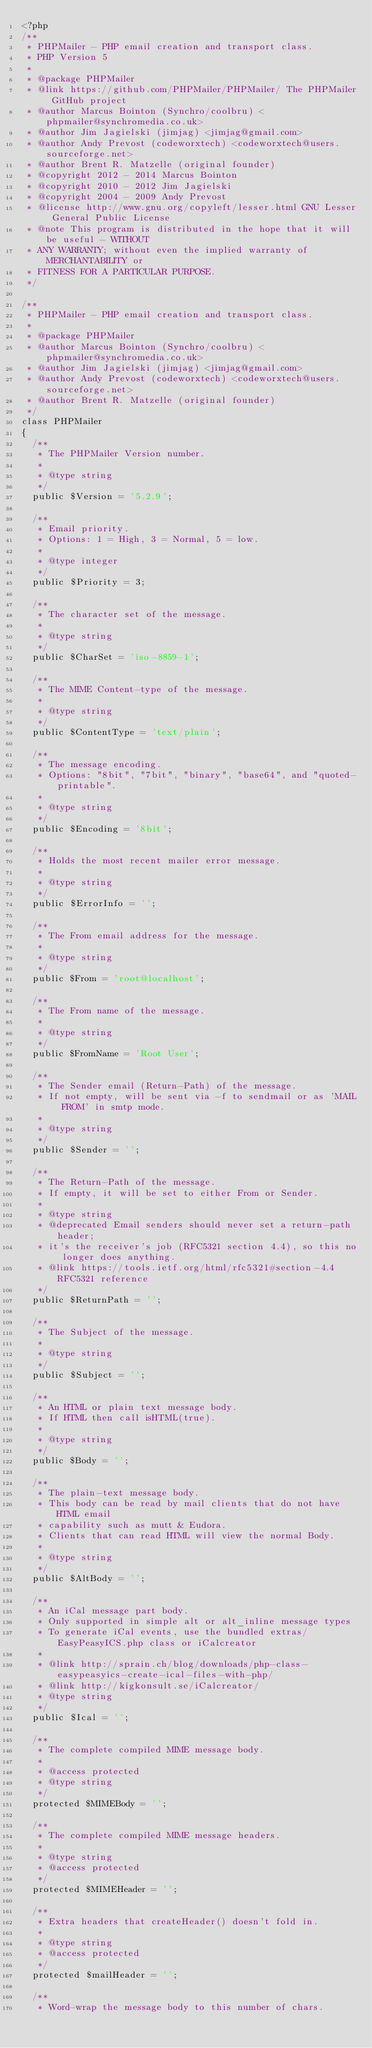<code> <loc_0><loc_0><loc_500><loc_500><_PHP_><?php
/**
 * PHPMailer - PHP email creation and transport class.
 * PHP Version 5
 *
 * @package PHPMailer
 * @link https://github.com/PHPMailer/PHPMailer/ The PHPMailer GitHub project
 * @author Marcus Bointon (Synchro/coolbru) <phpmailer@synchromedia.co.uk>
 * @author Jim Jagielski (jimjag) <jimjag@gmail.com>
 * @author Andy Prevost (codeworxtech) <codeworxtech@users.sourceforge.net>
 * @author Brent R. Matzelle (original founder)
 * @copyright 2012 - 2014 Marcus Bointon
 * @copyright 2010 - 2012 Jim Jagielski
 * @copyright 2004 - 2009 Andy Prevost
 * @license http://www.gnu.org/copyleft/lesser.html GNU Lesser General Public License
 * @note This program is distributed in the hope that it will be useful - WITHOUT
 * ANY WARRANTY; without even the implied warranty of MERCHANTABILITY or
 * FITNESS FOR A PARTICULAR PURPOSE.
 */

/**
 * PHPMailer - PHP email creation and transport class.
 *
 * @package PHPMailer
 * @author Marcus Bointon (Synchro/coolbru) <phpmailer@synchromedia.co.uk>
 * @author Jim Jagielski (jimjag) <jimjag@gmail.com>
 * @author Andy Prevost (codeworxtech) <codeworxtech@users.sourceforge.net>
 * @author Brent R. Matzelle (original founder)
 */
class PHPMailer
{
	/**
	 * The PHPMailer Version number.
	 *
	 * @type string
	 */
	public $Version = '5.2.9';

	/**
	 * Email priority.
	 * Options: 1 = High, 3 = Normal, 5 = low.
	 *
	 * @type integer
	 */
	public $Priority = 3;

	/**
	 * The character set of the message.
	 *
	 * @type string
	 */
	public $CharSet = 'iso-8859-1';

	/**
	 * The MIME Content-type of the message.
	 *
	 * @type string
	 */
	public $ContentType = 'text/plain';

	/**
	 * The message encoding.
	 * Options: "8bit", "7bit", "binary", "base64", and "quoted-printable".
	 *
	 * @type string
	 */
	public $Encoding = '8bit';

	/**
	 * Holds the most recent mailer error message.
	 *
	 * @type string
	 */
	public $ErrorInfo = '';

	/**
	 * The From email address for the message.
	 *
	 * @type string
	 */
	public $From = 'root@localhost';

	/**
	 * The From name of the message.
	 *
	 * @type string
	 */
	public $FromName = 'Root User';

	/**
	 * The Sender email (Return-Path) of the message.
	 * If not empty, will be sent via -f to sendmail or as 'MAIL FROM' in smtp mode.
	 *
	 * @type string
	 */
	public $Sender = '';

	/**
	 * The Return-Path of the message.
	 * If empty, it will be set to either From or Sender.
	 *
	 * @type string
	 * @deprecated Email senders should never set a return-path header;
	 * it's the receiver's job (RFC5321 section 4.4), so this no longer does anything.
	 * @link https://tools.ietf.org/html/rfc5321#section-4.4 RFC5321 reference
	 */
	public $ReturnPath = '';

	/**
	 * The Subject of the message.
	 *
	 * @type string
	 */
	public $Subject = '';

	/**
	 * An HTML or plain text message body.
	 * If HTML then call isHTML(true).
	 *
	 * @type string
	 */
	public $Body = '';

	/**
	 * The plain-text message body.
	 * This body can be read by mail clients that do not have HTML email
	 * capability such as mutt & Eudora.
	 * Clients that can read HTML will view the normal Body.
	 *
	 * @type string
	 */
	public $AltBody = '';

	/**
	 * An iCal message part body.
	 * Only supported in simple alt or alt_inline message types
	 * To generate iCal events, use the bundled extras/EasyPeasyICS.php class or iCalcreator
	 *
	 * @link http://sprain.ch/blog/downloads/php-class-easypeasyics-create-ical-files-with-php/
	 * @link http://kigkonsult.se/iCalcreator/
	 * @type string
	 */
	public $Ical = '';

	/**
	 * The complete compiled MIME message body.
	 *
	 * @access protected
	 * @type string
	 */
	protected $MIMEBody = '';

	/**
	 * The complete compiled MIME message headers.
	 *
	 * @type string
	 * @access protected
	 */
	protected $MIMEHeader = '';

	/**
	 * Extra headers that createHeader() doesn't fold in.
	 *
	 * @type string
	 * @access protected
	 */
	protected $mailHeader = '';

	/**
	 * Word-wrap the message body to this number of chars.</code> 